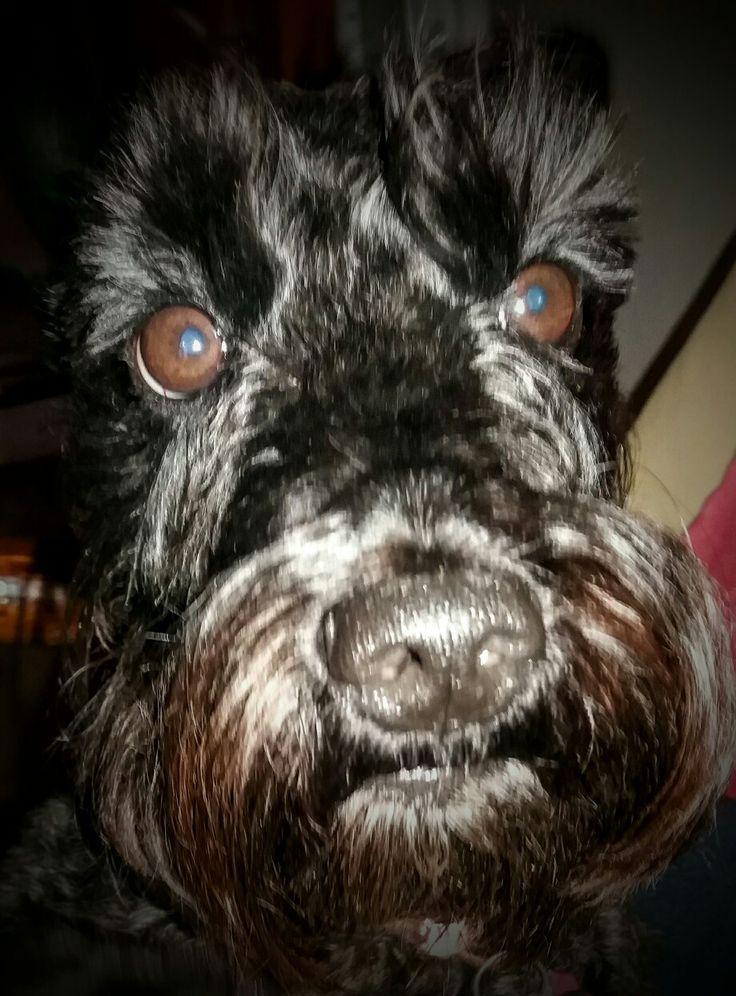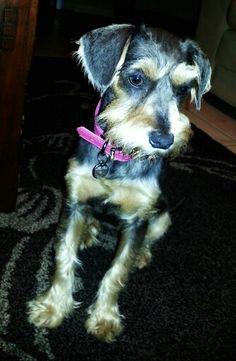The first image is the image on the left, the second image is the image on the right. For the images shown, is this caption "At least one schnauzer is sitting upright and wearing a collar with a dangling tag, but no other attire." true? Answer yes or no. Yes. The first image is the image on the left, the second image is the image on the right. Examine the images to the left and right. Is the description "One dog has its mouth open." accurate? Answer yes or no. No. 